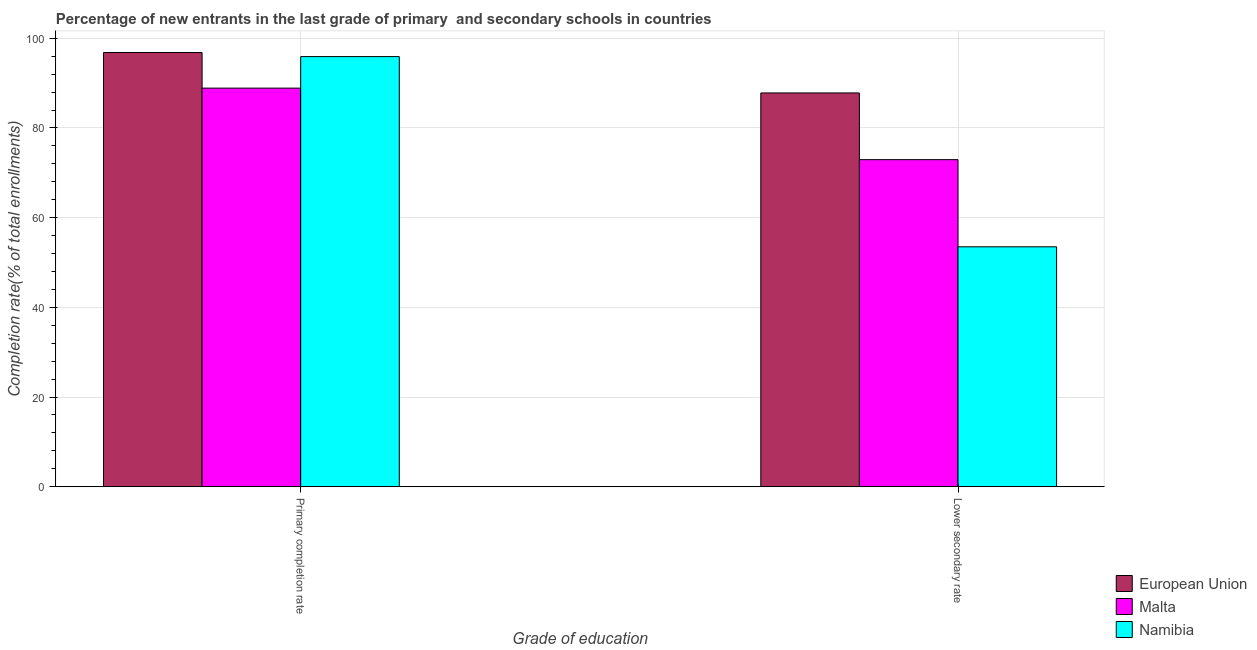How many groups of bars are there?
Provide a succinct answer. 2. How many bars are there on the 1st tick from the right?
Your answer should be compact. 3. What is the label of the 1st group of bars from the left?
Make the answer very short. Primary completion rate. What is the completion rate in primary schools in European Union?
Your answer should be compact. 96.82. Across all countries, what is the maximum completion rate in secondary schools?
Your answer should be compact. 87.81. Across all countries, what is the minimum completion rate in primary schools?
Make the answer very short. 88.88. In which country was the completion rate in secondary schools minimum?
Your answer should be very brief. Namibia. What is the total completion rate in primary schools in the graph?
Offer a very short reply. 281.62. What is the difference between the completion rate in secondary schools in European Union and that in Namibia?
Give a very brief answer. 34.31. What is the difference between the completion rate in primary schools in Malta and the completion rate in secondary schools in European Union?
Provide a short and direct response. 1.07. What is the average completion rate in primary schools per country?
Your answer should be very brief. 93.87. What is the difference between the completion rate in secondary schools and completion rate in primary schools in Namibia?
Your response must be concise. -42.41. What is the ratio of the completion rate in secondary schools in Namibia to that in European Union?
Your answer should be compact. 0.61. What does the 1st bar from the left in Primary completion rate represents?
Your response must be concise. European Union. How many countries are there in the graph?
Make the answer very short. 3. Does the graph contain any zero values?
Your answer should be very brief. No. Does the graph contain grids?
Provide a succinct answer. Yes. What is the title of the graph?
Make the answer very short. Percentage of new entrants in the last grade of primary  and secondary schools in countries. What is the label or title of the X-axis?
Offer a terse response. Grade of education. What is the label or title of the Y-axis?
Offer a terse response. Completion rate(% of total enrollments). What is the Completion rate(% of total enrollments) in European Union in Primary completion rate?
Your answer should be compact. 96.82. What is the Completion rate(% of total enrollments) of Malta in Primary completion rate?
Make the answer very short. 88.88. What is the Completion rate(% of total enrollments) in Namibia in Primary completion rate?
Give a very brief answer. 95.91. What is the Completion rate(% of total enrollments) in European Union in Lower secondary rate?
Keep it short and to the point. 87.81. What is the Completion rate(% of total enrollments) of Malta in Lower secondary rate?
Give a very brief answer. 72.94. What is the Completion rate(% of total enrollments) in Namibia in Lower secondary rate?
Your response must be concise. 53.5. Across all Grade of education, what is the maximum Completion rate(% of total enrollments) in European Union?
Give a very brief answer. 96.82. Across all Grade of education, what is the maximum Completion rate(% of total enrollments) of Malta?
Keep it short and to the point. 88.88. Across all Grade of education, what is the maximum Completion rate(% of total enrollments) of Namibia?
Your answer should be compact. 95.91. Across all Grade of education, what is the minimum Completion rate(% of total enrollments) in European Union?
Provide a short and direct response. 87.81. Across all Grade of education, what is the minimum Completion rate(% of total enrollments) in Malta?
Keep it short and to the point. 72.94. Across all Grade of education, what is the minimum Completion rate(% of total enrollments) of Namibia?
Offer a terse response. 53.5. What is the total Completion rate(% of total enrollments) of European Union in the graph?
Your answer should be very brief. 184.63. What is the total Completion rate(% of total enrollments) in Malta in the graph?
Provide a short and direct response. 161.82. What is the total Completion rate(% of total enrollments) of Namibia in the graph?
Keep it short and to the point. 149.41. What is the difference between the Completion rate(% of total enrollments) of European Union in Primary completion rate and that in Lower secondary rate?
Make the answer very short. 9.01. What is the difference between the Completion rate(% of total enrollments) in Malta in Primary completion rate and that in Lower secondary rate?
Provide a succinct answer. 15.95. What is the difference between the Completion rate(% of total enrollments) in Namibia in Primary completion rate and that in Lower secondary rate?
Offer a terse response. 42.41. What is the difference between the Completion rate(% of total enrollments) of European Union in Primary completion rate and the Completion rate(% of total enrollments) of Malta in Lower secondary rate?
Provide a succinct answer. 23.88. What is the difference between the Completion rate(% of total enrollments) in European Union in Primary completion rate and the Completion rate(% of total enrollments) in Namibia in Lower secondary rate?
Your answer should be compact. 43.32. What is the difference between the Completion rate(% of total enrollments) of Malta in Primary completion rate and the Completion rate(% of total enrollments) of Namibia in Lower secondary rate?
Ensure brevity in your answer.  35.38. What is the average Completion rate(% of total enrollments) of European Union per Grade of education?
Your response must be concise. 92.32. What is the average Completion rate(% of total enrollments) of Malta per Grade of education?
Your answer should be very brief. 80.91. What is the average Completion rate(% of total enrollments) in Namibia per Grade of education?
Offer a terse response. 74.71. What is the difference between the Completion rate(% of total enrollments) in European Union and Completion rate(% of total enrollments) in Malta in Primary completion rate?
Ensure brevity in your answer.  7.94. What is the difference between the Completion rate(% of total enrollments) of European Union and Completion rate(% of total enrollments) of Namibia in Primary completion rate?
Offer a very short reply. 0.91. What is the difference between the Completion rate(% of total enrollments) in Malta and Completion rate(% of total enrollments) in Namibia in Primary completion rate?
Your response must be concise. -7.03. What is the difference between the Completion rate(% of total enrollments) of European Union and Completion rate(% of total enrollments) of Malta in Lower secondary rate?
Provide a succinct answer. 14.87. What is the difference between the Completion rate(% of total enrollments) of European Union and Completion rate(% of total enrollments) of Namibia in Lower secondary rate?
Keep it short and to the point. 34.31. What is the difference between the Completion rate(% of total enrollments) of Malta and Completion rate(% of total enrollments) of Namibia in Lower secondary rate?
Provide a succinct answer. 19.44. What is the ratio of the Completion rate(% of total enrollments) in European Union in Primary completion rate to that in Lower secondary rate?
Make the answer very short. 1.1. What is the ratio of the Completion rate(% of total enrollments) in Malta in Primary completion rate to that in Lower secondary rate?
Provide a succinct answer. 1.22. What is the ratio of the Completion rate(% of total enrollments) in Namibia in Primary completion rate to that in Lower secondary rate?
Provide a succinct answer. 1.79. What is the difference between the highest and the second highest Completion rate(% of total enrollments) in European Union?
Keep it short and to the point. 9.01. What is the difference between the highest and the second highest Completion rate(% of total enrollments) of Malta?
Your answer should be compact. 15.95. What is the difference between the highest and the second highest Completion rate(% of total enrollments) in Namibia?
Your answer should be compact. 42.41. What is the difference between the highest and the lowest Completion rate(% of total enrollments) in European Union?
Ensure brevity in your answer.  9.01. What is the difference between the highest and the lowest Completion rate(% of total enrollments) in Malta?
Keep it short and to the point. 15.95. What is the difference between the highest and the lowest Completion rate(% of total enrollments) of Namibia?
Ensure brevity in your answer.  42.41. 